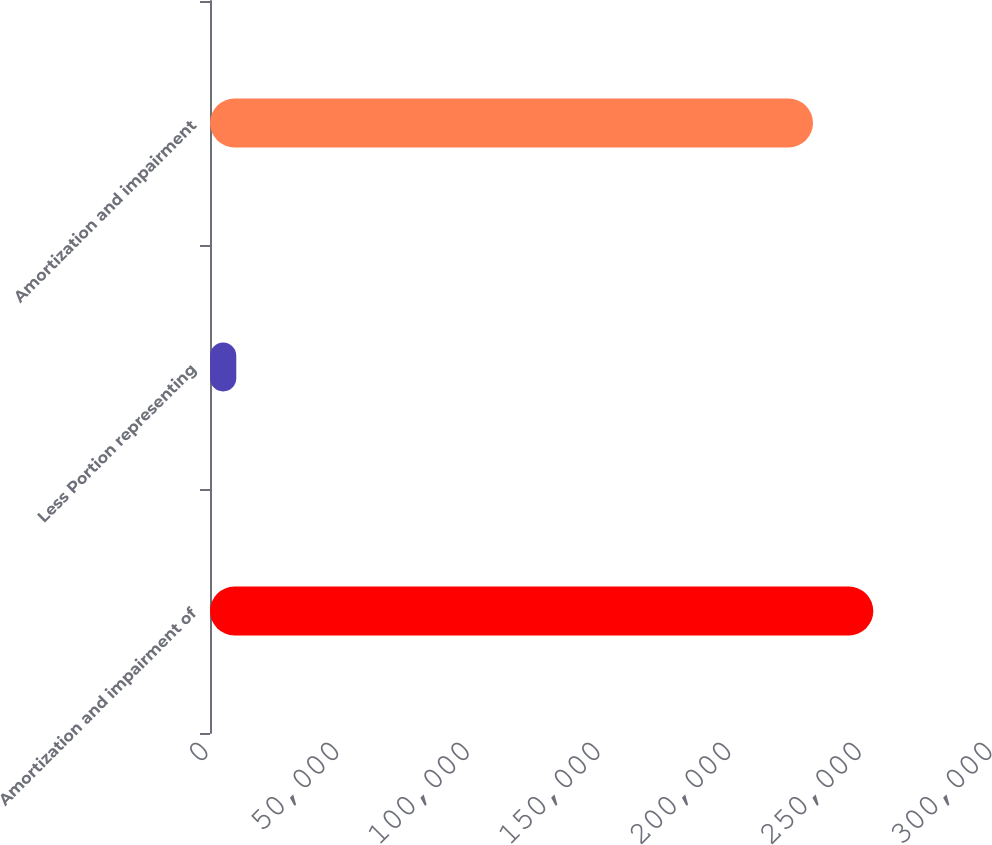Convert chart. <chart><loc_0><loc_0><loc_500><loc_500><bar_chart><fcel>Amortization and impairment of<fcel>Less Portion representing<fcel>Amortization and impairment<nl><fcel>253823<fcel>10060<fcel>230748<nl></chart> 